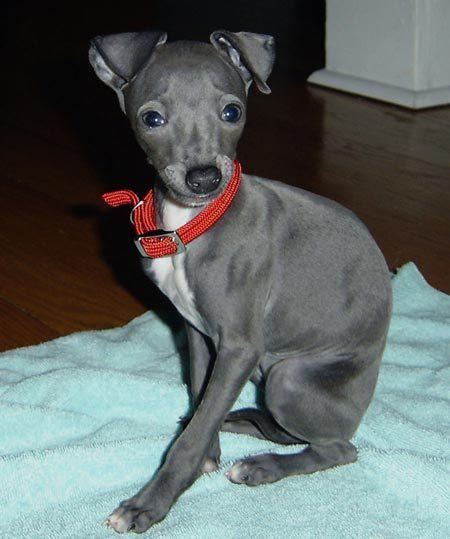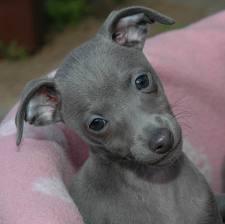The first image is the image on the left, the second image is the image on the right. Assess this claim about the two images: "Both of the images show dogs that look like puppies.". Correct or not? Answer yes or no. Yes. 